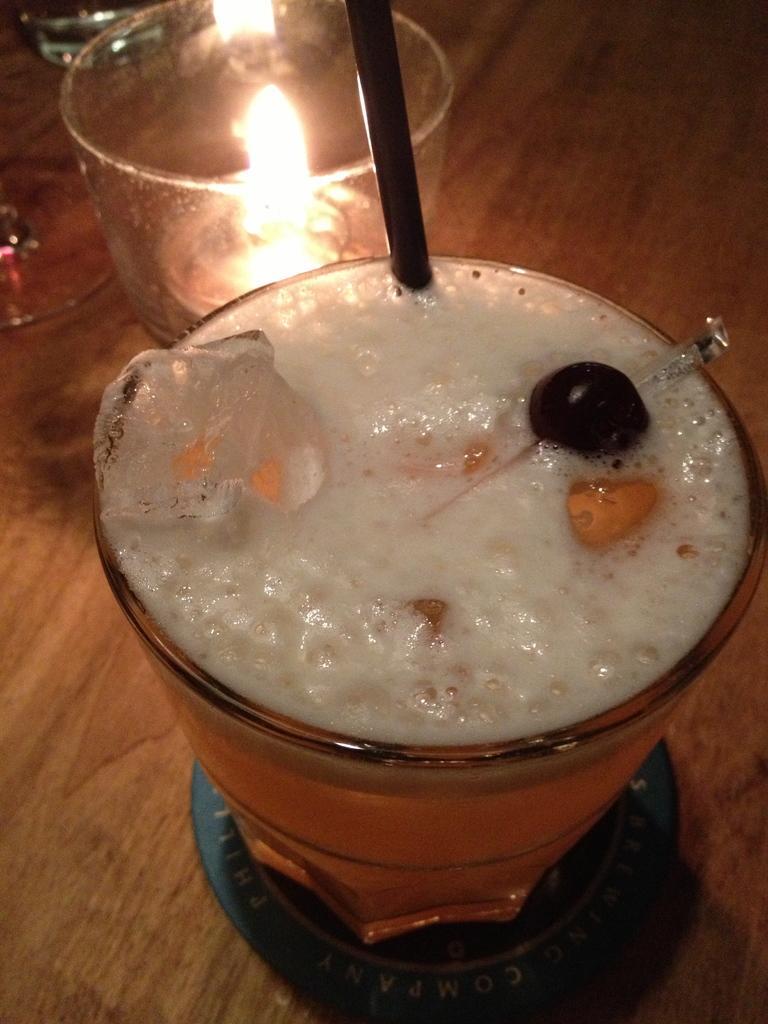In one or two sentences, can you explain what this image depicts? There is a glass in the center of the image, which contains liquid substances in it, there is a straw in the glass and there is a candle and other glasses in the image. 